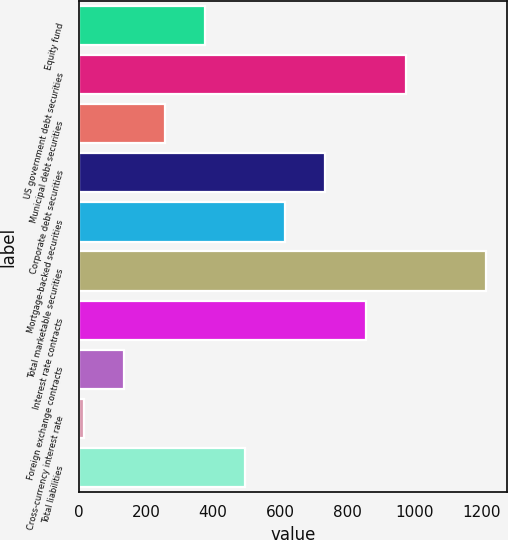Convert chart. <chart><loc_0><loc_0><loc_500><loc_500><bar_chart><fcel>Equity fund<fcel>US government debt securities<fcel>Municipal debt securities<fcel>Corporate debt securities<fcel>Mortgage-backed securities<fcel>Total marketable securities<fcel>Interest rate contracts<fcel>Foreign exchange contracts<fcel>Cross-currency interest rate<fcel>Total liabilities<nl><fcel>375.7<fcel>975.2<fcel>255.8<fcel>735.4<fcel>615.5<fcel>1215<fcel>855.3<fcel>135.9<fcel>16<fcel>495.6<nl></chart> 